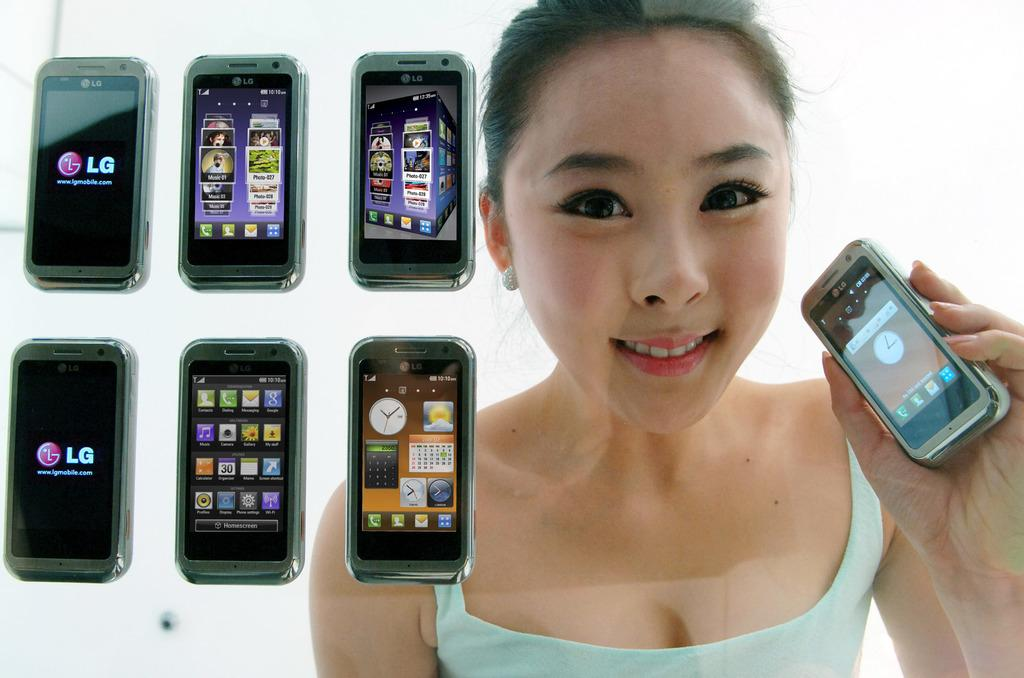Provide a one-sentence caption for the provided image. The woman is hold up a small phone with other LG phones shown next to her. 